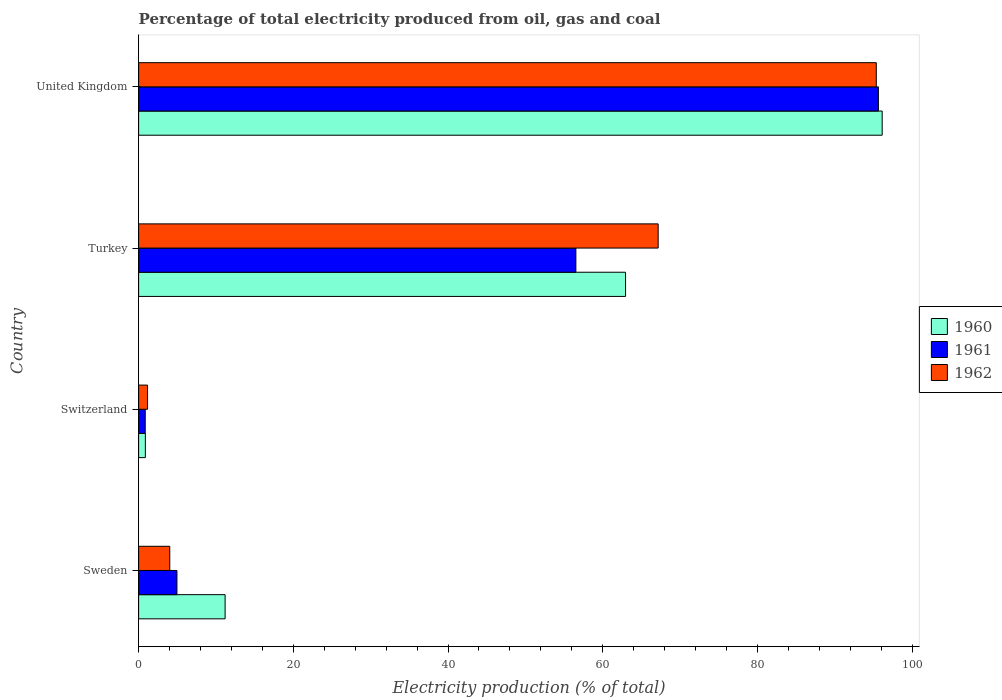Are the number of bars on each tick of the Y-axis equal?
Make the answer very short. Yes. What is the label of the 3rd group of bars from the top?
Keep it short and to the point. Switzerland. What is the electricity production in in 1960 in Turkey?
Give a very brief answer. 62.95. Across all countries, what is the maximum electricity production in in 1962?
Keep it short and to the point. 95.36. Across all countries, what is the minimum electricity production in in 1962?
Offer a terse response. 1.15. In which country was the electricity production in in 1962 maximum?
Your answer should be very brief. United Kingdom. In which country was the electricity production in in 1960 minimum?
Offer a very short reply. Switzerland. What is the total electricity production in in 1962 in the graph?
Provide a succinct answer. 167.7. What is the difference between the electricity production in in 1962 in Switzerland and that in Turkey?
Give a very brief answer. -66.01. What is the difference between the electricity production in in 1961 in United Kingdom and the electricity production in in 1962 in Switzerland?
Give a very brief answer. 94.48. What is the average electricity production in in 1961 per country?
Provide a succinct answer. 39.49. What is the difference between the electricity production in in 1962 and electricity production in in 1961 in Switzerland?
Ensure brevity in your answer.  0.3. In how many countries, is the electricity production in in 1962 greater than 76 %?
Offer a terse response. 1. What is the ratio of the electricity production in in 1960 in Switzerland to that in Turkey?
Your response must be concise. 0.01. Is the electricity production in in 1961 in Switzerland less than that in United Kingdom?
Your answer should be very brief. Yes. What is the difference between the highest and the second highest electricity production in in 1960?
Your answer should be very brief. 33.18. What is the difference between the highest and the lowest electricity production in in 1961?
Offer a terse response. 94.78. What does the 1st bar from the top in Switzerland represents?
Give a very brief answer. 1962. What does the 2nd bar from the bottom in Sweden represents?
Your answer should be compact. 1961. Is it the case that in every country, the sum of the electricity production in in 1961 and electricity production in in 1962 is greater than the electricity production in in 1960?
Provide a succinct answer. No. How many bars are there?
Offer a very short reply. 12. Are all the bars in the graph horizontal?
Offer a terse response. Yes. What is the difference between two consecutive major ticks on the X-axis?
Your answer should be compact. 20. Are the values on the major ticks of X-axis written in scientific E-notation?
Ensure brevity in your answer.  No. Does the graph contain grids?
Your answer should be very brief. No. How many legend labels are there?
Ensure brevity in your answer.  3. How are the legend labels stacked?
Provide a short and direct response. Vertical. What is the title of the graph?
Keep it short and to the point. Percentage of total electricity produced from oil, gas and coal. Does "2006" appear as one of the legend labels in the graph?
Your response must be concise. No. What is the label or title of the X-axis?
Keep it short and to the point. Electricity production (% of total). What is the Electricity production (% of total) of 1960 in Sweden?
Your answer should be very brief. 11.18. What is the Electricity production (% of total) in 1961 in Sweden?
Your response must be concise. 4.95. What is the Electricity production (% of total) in 1962 in Sweden?
Make the answer very short. 4.02. What is the Electricity production (% of total) of 1960 in Switzerland?
Give a very brief answer. 0.87. What is the Electricity production (% of total) of 1961 in Switzerland?
Provide a succinct answer. 0.85. What is the Electricity production (% of total) in 1962 in Switzerland?
Provide a short and direct response. 1.15. What is the Electricity production (% of total) in 1960 in Turkey?
Provide a short and direct response. 62.95. What is the Electricity production (% of total) of 1961 in Turkey?
Keep it short and to the point. 56.53. What is the Electricity production (% of total) of 1962 in Turkey?
Provide a succinct answer. 67.16. What is the Electricity production (% of total) of 1960 in United Kingdom?
Offer a terse response. 96.12. What is the Electricity production (% of total) of 1961 in United Kingdom?
Offer a very short reply. 95.64. What is the Electricity production (% of total) in 1962 in United Kingdom?
Provide a short and direct response. 95.36. Across all countries, what is the maximum Electricity production (% of total) in 1960?
Offer a very short reply. 96.12. Across all countries, what is the maximum Electricity production (% of total) of 1961?
Your response must be concise. 95.64. Across all countries, what is the maximum Electricity production (% of total) in 1962?
Keep it short and to the point. 95.36. Across all countries, what is the minimum Electricity production (% of total) of 1960?
Your answer should be compact. 0.87. Across all countries, what is the minimum Electricity production (% of total) of 1961?
Give a very brief answer. 0.85. Across all countries, what is the minimum Electricity production (% of total) of 1962?
Make the answer very short. 1.15. What is the total Electricity production (% of total) of 1960 in the graph?
Your answer should be very brief. 171.12. What is the total Electricity production (% of total) of 1961 in the graph?
Your answer should be compact. 157.97. What is the total Electricity production (% of total) of 1962 in the graph?
Keep it short and to the point. 167.7. What is the difference between the Electricity production (% of total) of 1960 in Sweden and that in Switzerland?
Ensure brevity in your answer.  10.31. What is the difference between the Electricity production (% of total) in 1961 in Sweden and that in Switzerland?
Offer a very short reply. 4.1. What is the difference between the Electricity production (% of total) of 1962 in Sweden and that in Switzerland?
Offer a terse response. 2.87. What is the difference between the Electricity production (% of total) of 1960 in Sweden and that in Turkey?
Provide a succinct answer. -51.77. What is the difference between the Electricity production (% of total) in 1961 in Sweden and that in Turkey?
Keep it short and to the point. -51.57. What is the difference between the Electricity production (% of total) in 1962 in Sweden and that in Turkey?
Make the answer very short. -63.14. What is the difference between the Electricity production (% of total) in 1960 in Sweden and that in United Kingdom?
Make the answer very short. -84.94. What is the difference between the Electricity production (% of total) of 1961 in Sweden and that in United Kingdom?
Make the answer very short. -90.68. What is the difference between the Electricity production (% of total) in 1962 in Sweden and that in United Kingdom?
Provide a short and direct response. -91.34. What is the difference between the Electricity production (% of total) in 1960 in Switzerland and that in Turkey?
Offer a very short reply. -62.08. What is the difference between the Electricity production (% of total) in 1961 in Switzerland and that in Turkey?
Your response must be concise. -55.67. What is the difference between the Electricity production (% of total) of 1962 in Switzerland and that in Turkey?
Offer a terse response. -66.01. What is the difference between the Electricity production (% of total) of 1960 in Switzerland and that in United Kingdom?
Keep it short and to the point. -95.25. What is the difference between the Electricity production (% of total) in 1961 in Switzerland and that in United Kingdom?
Make the answer very short. -94.78. What is the difference between the Electricity production (% of total) in 1962 in Switzerland and that in United Kingdom?
Your answer should be compact. -94.21. What is the difference between the Electricity production (% of total) of 1960 in Turkey and that in United Kingdom?
Ensure brevity in your answer.  -33.18. What is the difference between the Electricity production (% of total) in 1961 in Turkey and that in United Kingdom?
Keep it short and to the point. -39.11. What is the difference between the Electricity production (% of total) of 1962 in Turkey and that in United Kingdom?
Give a very brief answer. -28.2. What is the difference between the Electricity production (% of total) of 1960 in Sweden and the Electricity production (% of total) of 1961 in Switzerland?
Your response must be concise. 10.33. What is the difference between the Electricity production (% of total) of 1960 in Sweden and the Electricity production (% of total) of 1962 in Switzerland?
Your answer should be compact. 10.03. What is the difference between the Electricity production (% of total) of 1961 in Sweden and the Electricity production (% of total) of 1962 in Switzerland?
Make the answer very short. 3.8. What is the difference between the Electricity production (% of total) of 1960 in Sweden and the Electricity production (% of total) of 1961 in Turkey?
Offer a terse response. -45.35. What is the difference between the Electricity production (% of total) in 1960 in Sweden and the Electricity production (% of total) in 1962 in Turkey?
Keep it short and to the point. -55.98. What is the difference between the Electricity production (% of total) of 1961 in Sweden and the Electricity production (% of total) of 1962 in Turkey?
Provide a succinct answer. -62.21. What is the difference between the Electricity production (% of total) of 1960 in Sweden and the Electricity production (% of total) of 1961 in United Kingdom?
Your response must be concise. -84.46. What is the difference between the Electricity production (% of total) in 1960 in Sweden and the Electricity production (% of total) in 1962 in United Kingdom?
Give a very brief answer. -84.18. What is the difference between the Electricity production (% of total) of 1961 in Sweden and the Electricity production (% of total) of 1962 in United Kingdom?
Offer a very short reply. -90.41. What is the difference between the Electricity production (% of total) in 1960 in Switzerland and the Electricity production (% of total) in 1961 in Turkey?
Offer a terse response. -55.66. What is the difference between the Electricity production (% of total) of 1960 in Switzerland and the Electricity production (% of total) of 1962 in Turkey?
Your answer should be very brief. -66.29. What is the difference between the Electricity production (% of total) in 1961 in Switzerland and the Electricity production (% of total) in 1962 in Turkey?
Keep it short and to the point. -66.31. What is the difference between the Electricity production (% of total) in 1960 in Switzerland and the Electricity production (% of total) in 1961 in United Kingdom?
Your answer should be compact. -94.77. What is the difference between the Electricity production (% of total) in 1960 in Switzerland and the Electricity production (% of total) in 1962 in United Kingdom?
Ensure brevity in your answer.  -94.49. What is the difference between the Electricity production (% of total) of 1961 in Switzerland and the Electricity production (% of total) of 1962 in United Kingdom?
Provide a succinct answer. -94.51. What is the difference between the Electricity production (% of total) in 1960 in Turkey and the Electricity production (% of total) in 1961 in United Kingdom?
Provide a succinct answer. -32.69. What is the difference between the Electricity production (% of total) in 1960 in Turkey and the Electricity production (% of total) in 1962 in United Kingdom?
Offer a very short reply. -32.41. What is the difference between the Electricity production (% of total) of 1961 in Turkey and the Electricity production (% of total) of 1962 in United Kingdom?
Offer a terse response. -38.83. What is the average Electricity production (% of total) of 1960 per country?
Give a very brief answer. 42.78. What is the average Electricity production (% of total) in 1961 per country?
Offer a terse response. 39.49. What is the average Electricity production (% of total) of 1962 per country?
Give a very brief answer. 41.93. What is the difference between the Electricity production (% of total) of 1960 and Electricity production (% of total) of 1961 in Sweden?
Keep it short and to the point. 6.23. What is the difference between the Electricity production (% of total) of 1960 and Electricity production (% of total) of 1962 in Sweden?
Offer a terse response. 7.16. What is the difference between the Electricity production (% of total) of 1961 and Electricity production (% of total) of 1962 in Sweden?
Offer a very short reply. 0.93. What is the difference between the Electricity production (% of total) in 1960 and Electricity production (% of total) in 1961 in Switzerland?
Provide a short and direct response. 0.02. What is the difference between the Electricity production (% of total) of 1960 and Electricity production (% of total) of 1962 in Switzerland?
Your response must be concise. -0.28. What is the difference between the Electricity production (% of total) of 1961 and Electricity production (% of total) of 1962 in Switzerland?
Offer a terse response. -0.3. What is the difference between the Electricity production (% of total) of 1960 and Electricity production (% of total) of 1961 in Turkey?
Your answer should be compact. 6.42. What is the difference between the Electricity production (% of total) of 1960 and Electricity production (% of total) of 1962 in Turkey?
Provide a short and direct response. -4.21. What is the difference between the Electricity production (% of total) of 1961 and Electricity production (% of total) of 1962 in Turkey?
Your response must be concise. -10.64. What is the difference between the Electricity production (% of total) in 1960 and Electricity production (% of total) in 1961 in United Kingdom?
Provide a succinct answer. 0.49. What is the difference between the Electricity production (% of total) in 1960 and Electricity production (% of total) in 1962 in United Kingdom?
Your answer should be compact. 0.76. What is the difference between the Electricity production (% of total) in 1961 and Electricity production (% of total) in 1962 in United Kingdom?
Keep it short and to the point. 0.28. What is the ratio of the Electricity production (% of total) in 1960 in Sweden to that in Switzerland?
Offer a very short reply. 12.86. What is the ratio of the Electricity production (% of total) in 1961 in Sweden to that in Switzerland?
Provide a succinct answer. 5.8. What is the ratio of the Electricity production (% of total) of 1962 in Sweden to that in Switzerland?
Your answer should be compact. 3.49. What is the ratio of the Electricity production (% of total) in 1960 in Sweden to that in Turkey?
Provide a short and direct response. 0.18. What is the ratio of the Electricity production (% of total) in 1961 in Sweden to that in Turkey?
Keep it short and to the point. 0.09. What is the ratio of the Electricity production (% of total) of 1962 in Sweden to that in Turkey?
Give a very brief answer. 0.06. What is the ratio of the Electricity production (% of total) in 1960 in Sweden to that in United Kingdom?
Provide a succinct answer. 0.12. What is the ratio of the Electricity production (% of total) of 1961 in Sweden to that in United Kingdom?
Ensure brevity in your answer.  0.05. What is the ratio of the Electricity production (% of total) in 1962 in Sweden to that in United Kingdom?
Provide a succinct answer. 0.04. What is the ratio of the Electricity production (% of total) of 1960 in Switzerland to that in Turkey?
Provide a short and direct response. 0.01. What is the ratio of the Electricity production (% of total) of 1961 in Switzerland to that in Turkey?
Provide a succinct answer. 0.02. What is the ratio of the Electricity production (% of total) of 1962 in Switzerland to that in Turkey?
Your answer should be very brief. 0.02. What is the ratio of the Electricity production (% of total) in 1960 in Switzerland to that in United Kingdom?
Make the answer very short. 0.01. What is the ratio of the Electricity production (% of total) in 1961 in Switzerland to that in United Kingdom?
Offer a very short reply. 0.01. What is the ratio of the Electricity production (% of total) of 1962 in Switzerland to that in United Kingdom?
Ensure brevity in your answer.  0.01. What is the ratio of the Electricity production (% of total) of 1960 in Turkey to that in United Kingdom?
Keep it short and to the point. 0.65. What is the ratio of the Electricity production (% of total) of 1961 in Turkey to that in United Kingdom?
Offer a terse response. 0.59. What is the ratio of the Electricity production (% of total) in 1962 in Turkey to that in United Kingdom?
Your answer should be compact. 0.7. What is the difference between the highest and the second highest Electricity production (% of total) in 1960?
Provide a short and direct response. 33.18. What is the difference between the highest and the second highest Electricity production (% of total) of 1961?
Offer a very short reply. 39.11. What is the difference between the highest and the second highest Electricity production (% of total) of 1962?
Your response must be concise. 28.2. What is the difference between the highest and the lowest Electricity production (% of total) in 1960?
Provide a short and direct response. 95.25. What is the difference between the highest and the lowest Electricity production (% of total) of 1961?
Offer a very short reply. 94.78. What is the difference between the highest and the lowest Electricity production (% of total) in 1962?
Offer a very short reply. 94.21. 